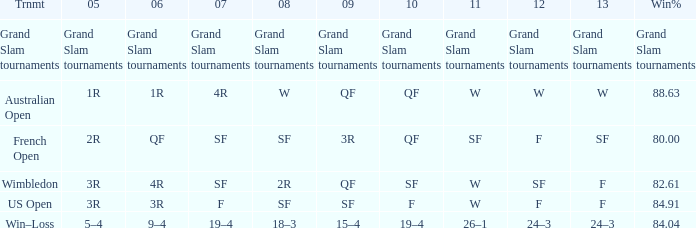What in 2007 has a 2010 of qf, and a 2012 of w? 4R. 